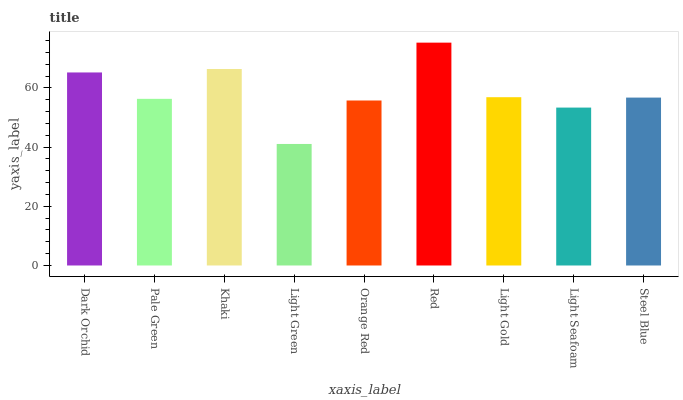Is Pale Green the minimum?
Answer yes or no. No. Is Pale Green the maximum?
Answer yes or no. No. Is Dark Orchid greater than Pale Green?
Answer yes or no. Yes. Is Pale Green less than Dark Orchid?
Answer yes or no. Yes. Is Pale Green greater than Dark Orchid?
Answer yes or no. No. Is Dark Orchid less than Pale Green?
Answer yes or no. No. Is Steel Blue the high median?
Answer yes or no. Yes. Is Steel Blue the low median?
Answer yes or no. Yes. Is Light Gold the high median?
Answer yes or no. No. Is Light Green the low median?
Answer yes or no. No. 